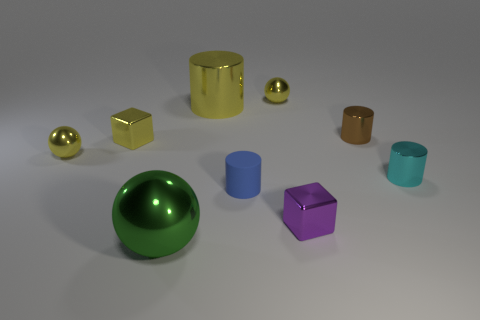The brown object is what shape?
Provide a succinct answer. Cylinder. Are there more small rubber things on the right side of the tiny blue thing than metal blocks?
Make the answer very short. No. What is the shape of the rubber object that is in front of the brown object?
Your response must be concise. Cylinder. How many other things are there of the same shape as the small cyan object?
Your answer should be compact. 3. Is the small yellow cube that is to the left of the small cyan metal cylinder made of the same material as the tiny purple block?
Your answer should be compact. Yes. Are there the same number of yellow metallic things that are behind the brown cylinder and yellow objects in front of the purple metallic object?
Offer a very short reply. No. There is a sphere that is on the left side of the green thing; how big is it?
Make the answer very short. Small. Is there a small blue object that has the same material as the tiny brown thing?
Ensure brevity in your answer.  No. Is the color of the tiny shiny ball that is to the left of the large green thing the same as the small rubber cylinder?
Your response must be concise. No. Are there an equal number of metal balls that are in front of the tiny brown thing and large brown metal objects?
Offer a very short reply. No. 